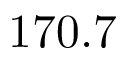<formula> <loc_0><loc_0><loc_500><loc_500>1 7 0 . 7</formula> 